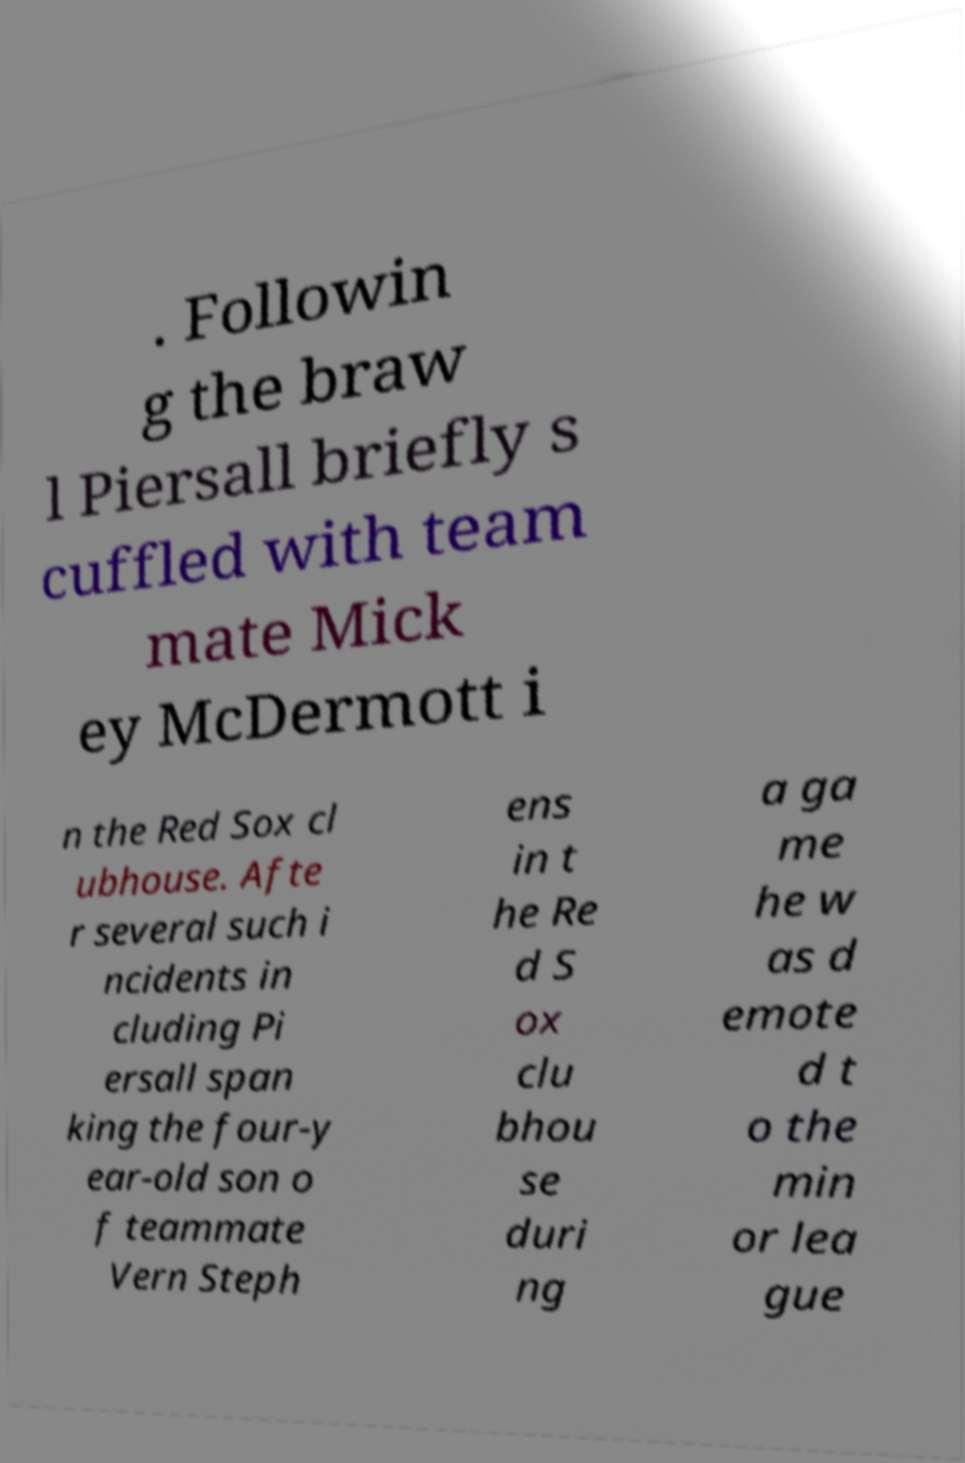For documentation purposes, I need the text within this image transcribed. Could you provide that? . Followin g the braw l Piersall briefly s cuffled with team mate Mick ey McDermott i n the Red Sox cl ubhouse. Afte r several such i ncidents in cluding Pi ersall span king the four-y ear-old son o f teammate Vern Steph ens in t he Re d S ox clu bhou se duri ng a ga me he w as d emote d t o the min or lea gue 